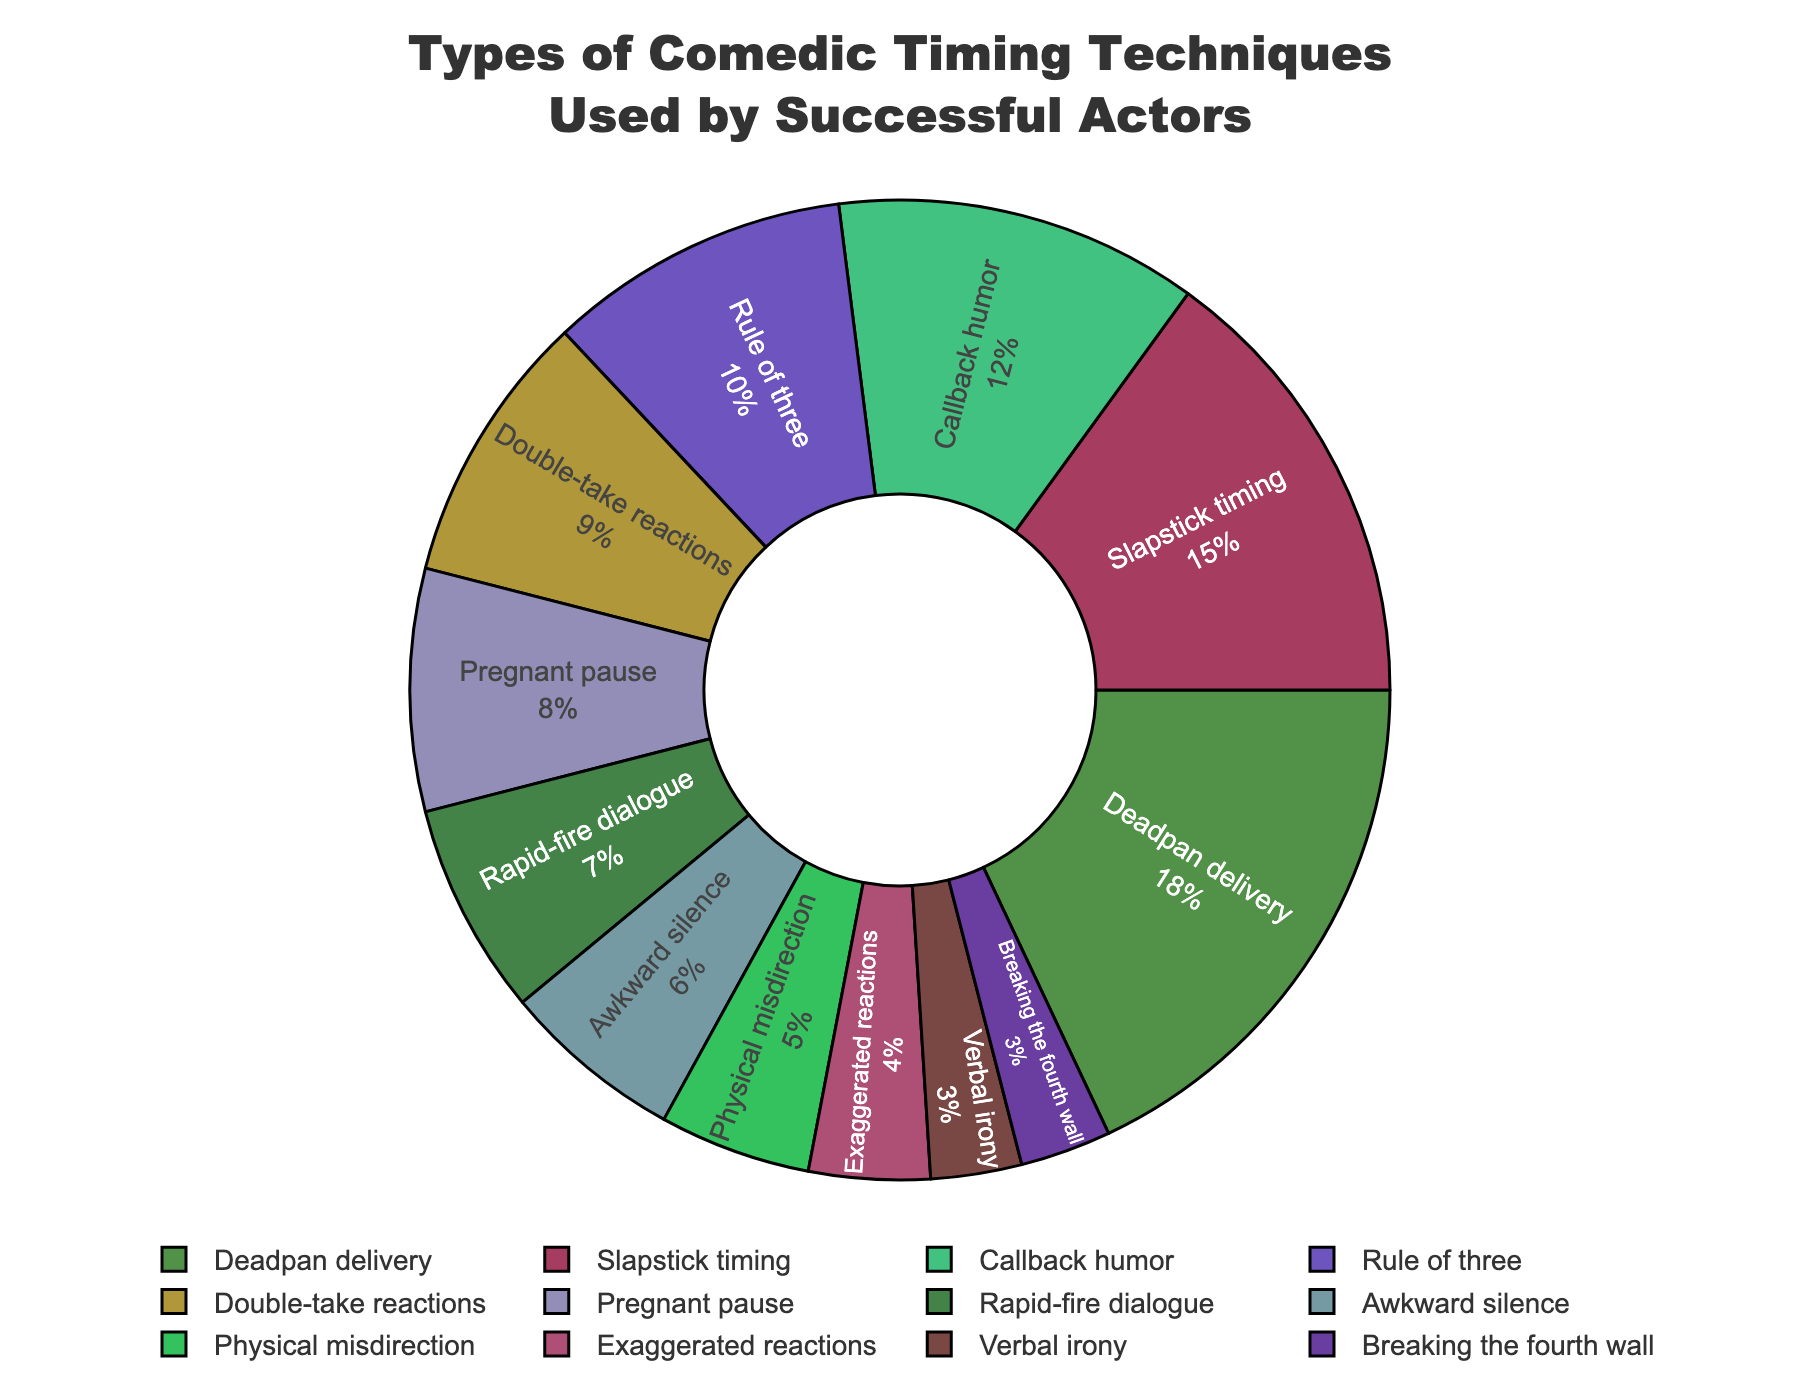What's the most frequently used comedic timing technique according to the figure? The "Deadpan delivery" segment is the largest in the pie chart, indicating it has the highest percentage.
Answer: Deadpan delivery Which technique is used just as frequently as "Verbal irony"? Both "Verbal irony" and "Breaking the fourth wall" have the same percentage values of 3%, making them equally used.
Answer: Breaking the fourth wall What is the combined usage percentage of "Awkward silence" and "Physical misdirection"? "Awkward silence" has 6% and "Physical misdirection" has 5%. Summing these percentages, we get 6 + 5 = 11%.
Answer: 11% Which technique is more popular: "Rapid-fire dialogue" or "Pregnant pause"? By comparing the segments, "Rapid-fire dialogue" has 7% while "Pregnant pause" has 8%. Since 8% is greater than 7%, "Pregnant pause" is more popular.
Answer: Pregnant pause How many techniques have a usage percentage greater than or equal to 10%? The techniques meeting this criterion are "Deadpan delivery" (18%), "Slapstick timing" (15%), "Callback humor" (12%), and "Rule of three" (10%). Counting these gives us 4 techniques.
Answer: 4 What is the difference in usage percentages between "Exaggerated reactions" and "Double-take reactions"? "Double-take reactions" has 9% and "Exaggerated reactions" has 4%. The difference is calculated as 9% - 4% = 5%.
Answer: 5% Which comedic timing technique is the least frequently used? The smallest segment in the pie chart corresponds to the lowest percentage value, which is "Verbal irony" and "Breaking the fourth wall," both at 3%.
Answer: Verbal irony How many techniques have a usage percentage less than 10%? The techniques with percentages less than 10% are "Double-take reactions" (9%), "Pregnant pause" (8%), "Rapid-fire dialogue" (7%), "Awkward silence" (6%), "Physical misdirection" (5%), "Exaggerated reactions" (4%), "Verbal irony" (3%), and "Breaking the fourth wall" (3%). This totals 8 techniques.
Answer: 8 